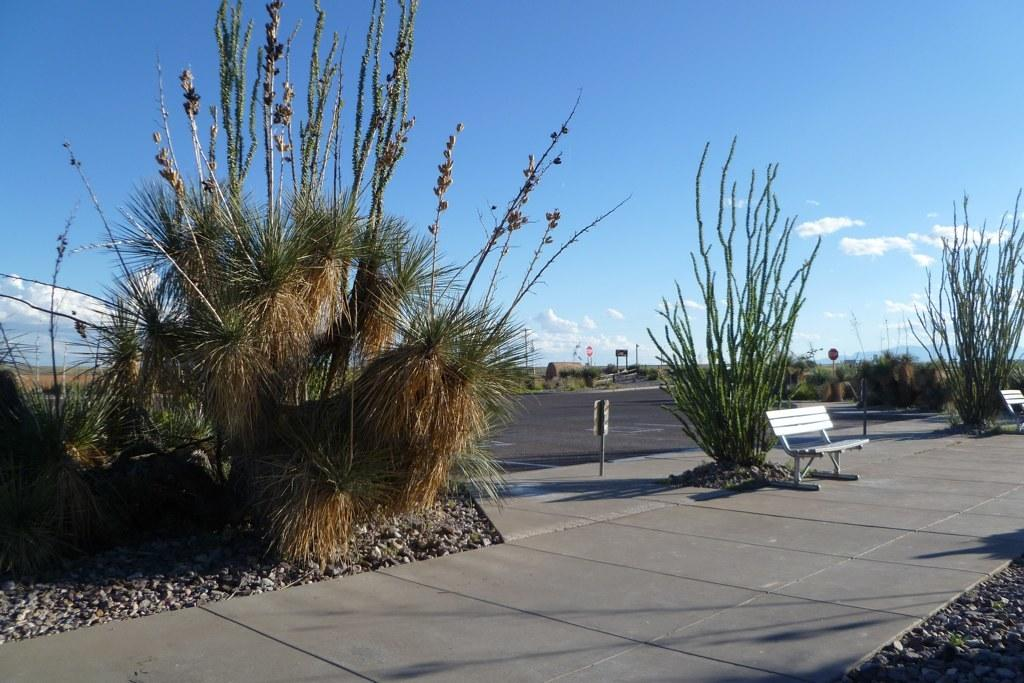What can be seen in the sky in the image? The sky is visible in the image. What type of vegetation is present in the image? There are plants in the image. What kind of pathway is depicted in the image? There is a road in the image. What type of seating is available in the image? There are benches in the image. What material is present in the image that might be used for paving or decoration? There are stones in the image. What structures are present in the image that might be used for supporting wires or signs? There are poles in the image. What type of information might be displayed in the image? There is a sign board in the image. What type of juice is being served in the image? There is no juice present in the image. What type of needle is being used to sew a scarf in the image? There is no needle or scarf present in the image. 